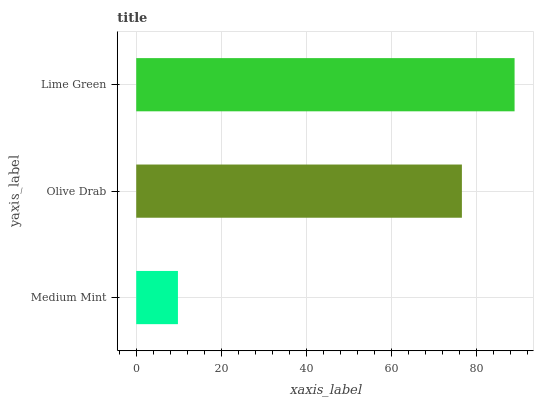Is Medium Mint the minimum?
Answer yes or no. Yes. Is Lime Green the maximum?
Answer yes or no. Yes. Is Olive Drab the minimum?
Answer yes or no. No. Is Olive Drab the maximum?
Answer yes or no. No. Is Olive Drab greater than Medium Mint?
Answer yes or no. Yes. Is Medium Mint less than Olive Drab?
Answer yes or no. Yes. Is Medium Mint greater than Olive Drab?
Answer yes or no. No. Is Olive Drab less than Medium Mint?
Answer yes or no. No. Is Olive Drab the high median?
Answer yes or no. Yes. Is Olive Drab the low median?
Answer yes or no. Yes. Is Medium Mint the high median?
Answer yes or no. No. Is Medium Mint the low median?
Answer yes or no. No. 